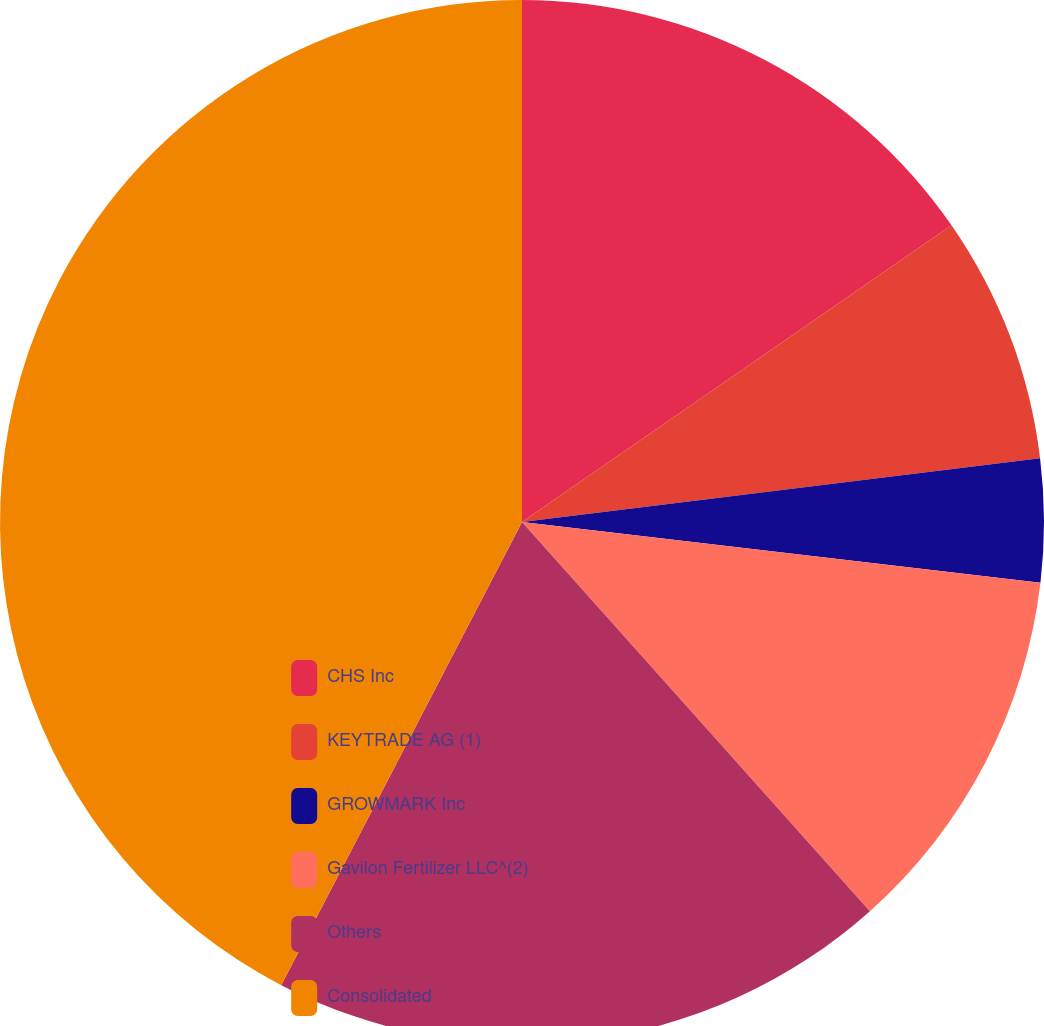<chart> <loc_0><loc_0><loc_500><loc_500><pie_chart><fcel>CHS Inc<fcel>KEYTRADE AG (1)<fcel>GROWMARK Inc<fcel>Gavilon Fertilizer LLC^(2)<fcel>Others<fcel>Consolidated<nl><fcel>15.38%<fcel>7.67%<fcel>3.81%<fcel>11.53%<fcel>19.24%<fcel>42.37%<nl></chart> 